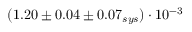<formula> <loc_0><loc_0><loc_500><loc_500>( 1 . 2 0 \pm 0 . 0 4 \pm 0 . 0 7 _ { s y s } ) \cdot 1 0 ^ { - 3 }</formula> 